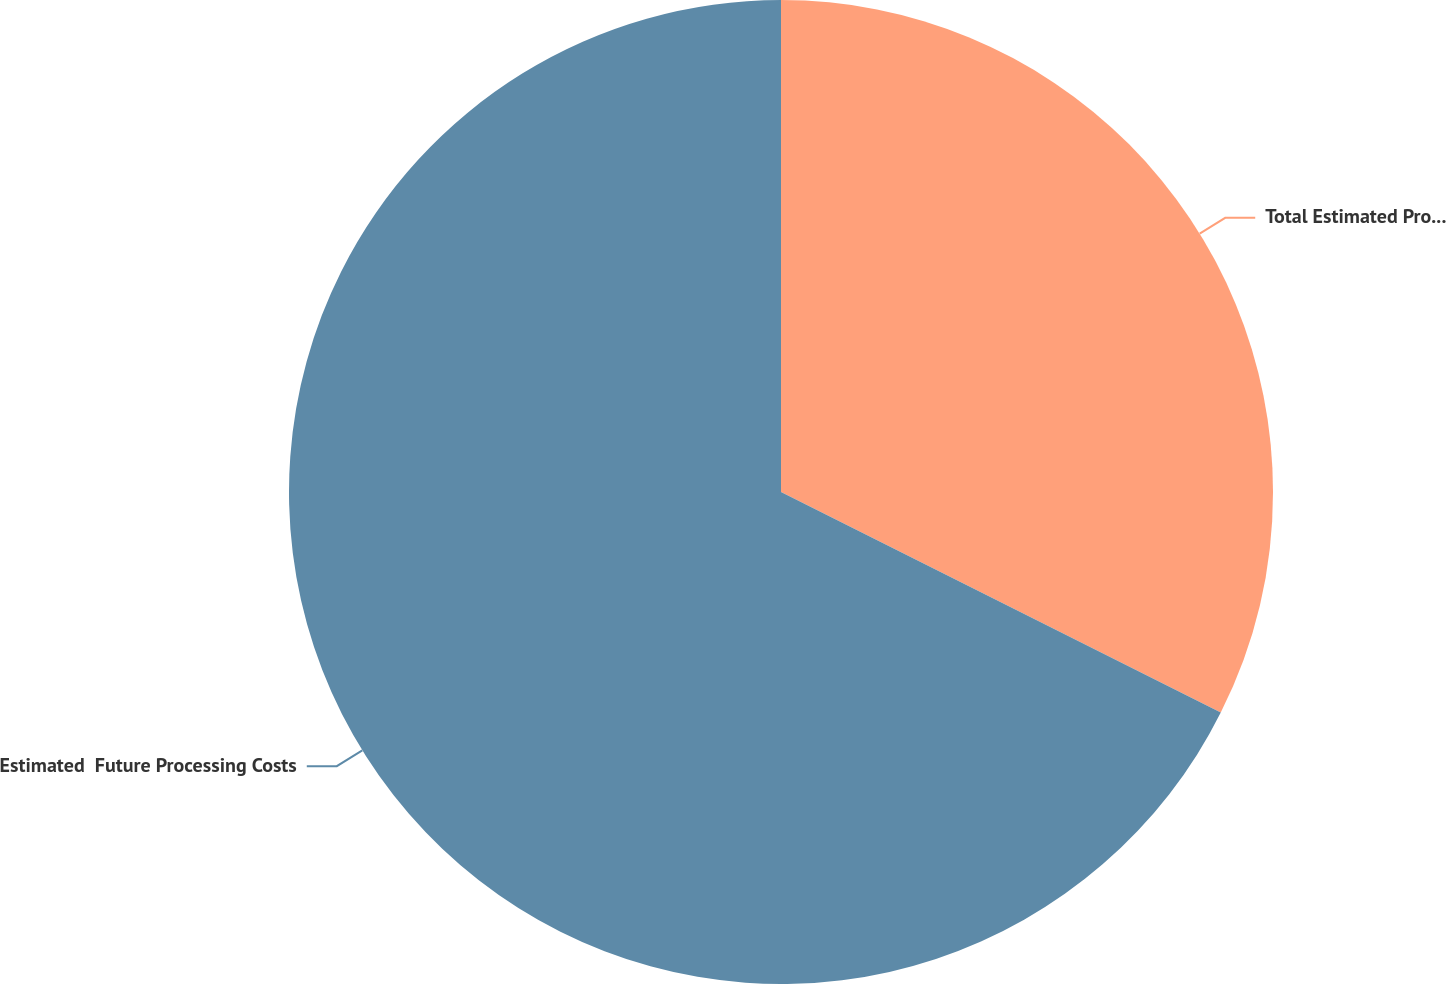<chart> <loc_0><loc_0><loc_500><loc_500><pie_chart><fcel>Total Estimated Production Costs<fcel>Estimated  Future Processing Costs<nl><fcel>32.4%<fcel>67.6%<nl></chart> 